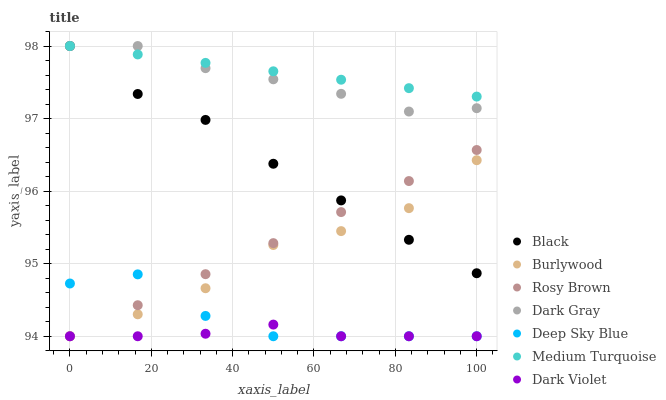Does Dark Violet have the minimum area under the curve?
Answer yes or no. Yes. Does Medium Turquoise have the maximum area under the curve?
Answer yes or no. Yes. Does Burlywood have the minimum area under the curve?
Answer yes or no. No. Does Burlywood have the maximum area under the curve?
Answer yes or no. No. Is Rosy Brown the smoothest?
Answer yes or no. Yes. Is Deep Sky Blue the roughest?
Answer yes or no. Yes. Is Burlywood the smoothest?
Answer yes or no. No. Is Burlywood the roughest?
Answer yes or no. No. Does Deep Sky Blue have the lowest value?
Answer yes or no. Yes. Does Dark Gray have the lowest value?
Answer yes or no. No. Does Medium Turquoise have the highest value?
Answer yes or no. Yes. Does Burlywood have the highest value?
Answer yes or no. No. Is Rosy Brown less than Medium Turquoise?
Answer yes or no. Yes. Is Black greater than Dark Violet?
Answer yes or no. Yes. Does Black intersect Medium Turquoise?
Answer yes or no. Yes. Is Black less than Medium Turquoise?
Answer yes or no. No. Is Black greater than Medium Turquoise?
Answer yes or no. No. Does Rosy Brown intersect Medium Turquoise?
Answer yes or no. No. 